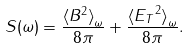Convert formula to latex. <formula><loc_0><loc_0><loc_500><loc_500>S ( { \omega } ) = \frac { { \langle B ^ { 2 } \rangle } _ { \omega } } { 8 \pi } + \frac { { \langle { E _ { T } } ^ { 2 } \rangle } _ { \omega } } { 8 \pi } .</formula> 